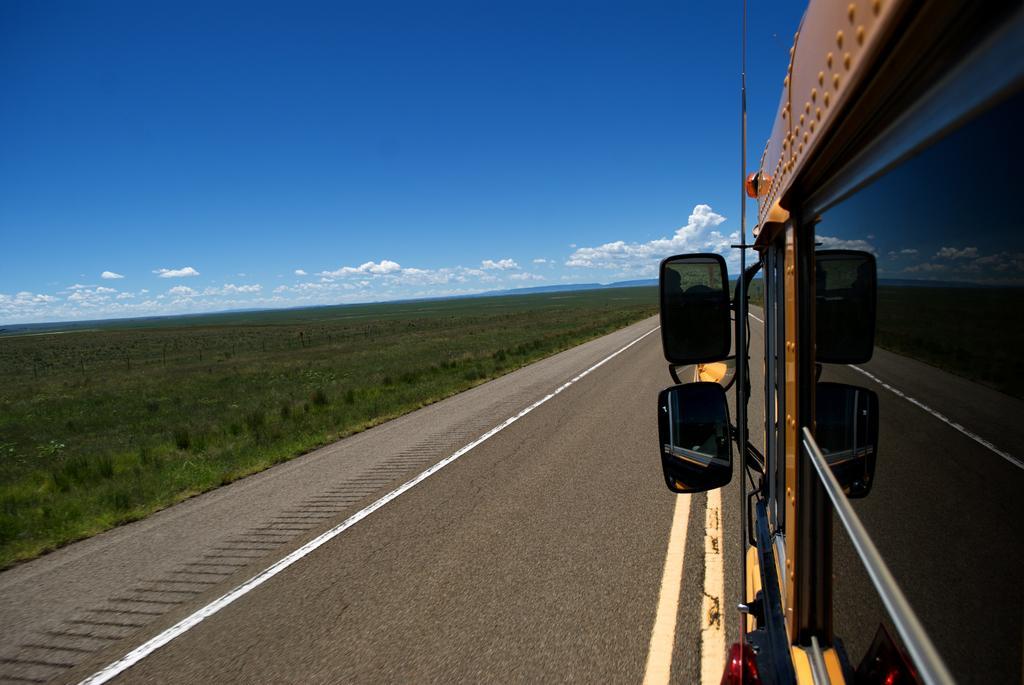Can you describe this image briefly? In this image I can see a vehicle,mirrors,glass window and rods. I can see the green grass and sky is in blue and white color. 